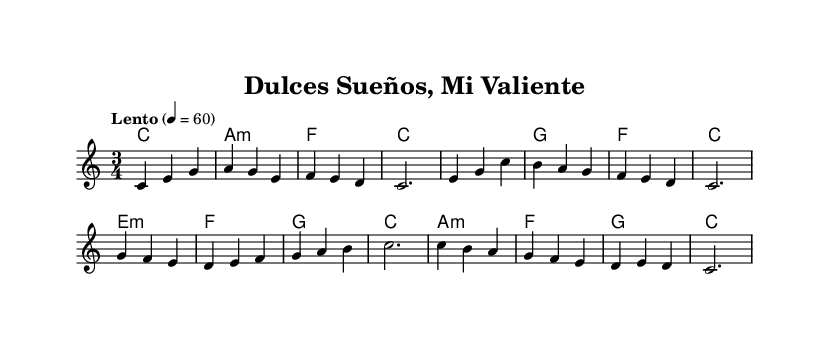What is the key signature of this music? The key signature is C major, which has no sharps or flats.
Answer: C major What is the time signature? The time signature is indicated at the beginning of the piece and shows three beats per measure.
Answer: 3/4 What is the tempo marking for this piece? The tempo marking at the beginning specifies a speed of Lento, which means slow, with a metronome marking of 60 beats per minute.
Answer: Lento How many measures are in the melody? By counting the individual measures in the melody section, there are a total of 8 measures.
Answer: 8 What type of harmony is primarily used in this lullaby? The harmony primarily consists of triadic chords that commonly appear in lullabies, including major and minor chords.
Answer: Triadic chords Which part of the sheet music indicates the instrumental voicing? The use of the word "Voice" in the scored section indicates that this part is meant for melody, while "ChordNames" indicates harmony.
Answer: Voice What is the emotional character intended for this lullaby? The gentle and soothing qualities of the melody and tempo are designed to comfort children, especially those overcoming difficulties.
Answer: Soothing 